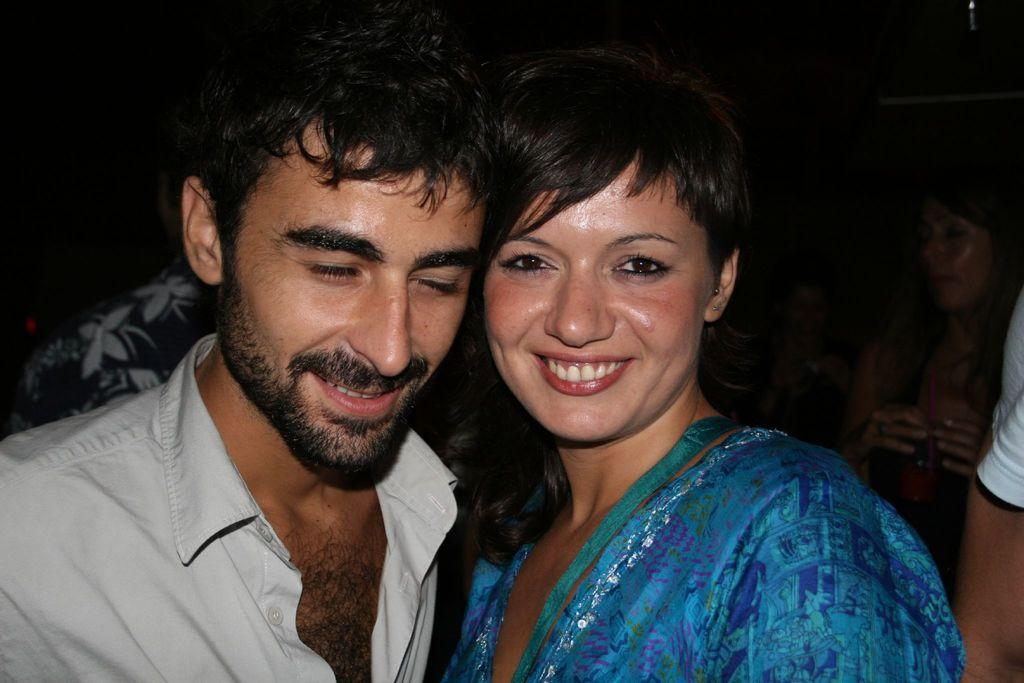What is present in the image? There are people in the image. Can you describe the expressions on some of the faces in the image? There are smiles visible on some faces in the image. How many chairs are visible in the image? There is no mention of chairs in the provided facts, so it cannot be determined from the image. Is there a rabbit present in the image? There is no rabbit present in the image. What type of club can be seen in the image? There is no club present in the image. 